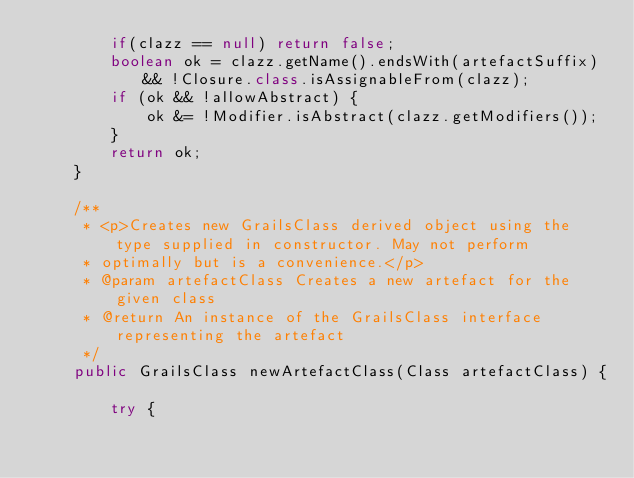Convert code to text. <code><loc_0><loc_0><loc_500><loc_500><_Java_>        if(clazz == null) return false;
        boolean ok = clazz.getName().endsWith(artefactSuffix) && !Closure.class.isAssignableFrom(clazz);
        if (ok && !allowAbstract) {
            ok &= !Modifier.isAbstract(clazz.getModifiers());
        }
        return ok;
    }

    /**
     * <p>Creates new GrailsClass derived object using the type supplied in constructor. May not perform
     * optimally but is a convenience.</p>
     * @param artefactClass Creates a new artefact for the given class
     * @return An instance of the GrailsClass interface representing the artefact
     */
    public GrailsClass newArtefactClass(Class artefactClass) {

        try {</code> 